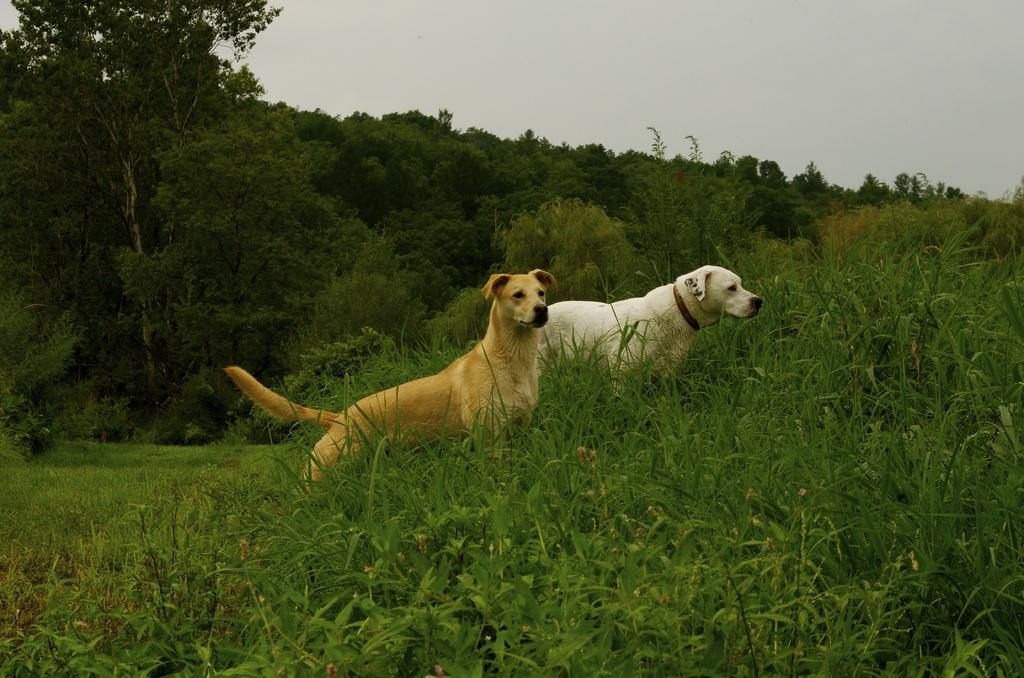How many dogs are present in the image? There are two dogs in the image. What other living organisms can be seen in the image? There are plants in the image. What type of vegetation is visible in the image? There is grass and trees visible in the image. What is visible at the top of the image? The sky is visible at the top of the image. What type of coal can be seen in the image? There is no coal present in the image. Can you describe the weather conditions in the image? The provided facts do not give any information about the weather conditions in the image. 